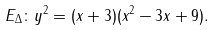<formula> <loc_0><loc_0><loc_500><loc_500>E _ { \Delta } \colon y ^ { 2 } = ( x + 3 ) ( x ^ { 2 } - 3 x + 9 ) .</formula> 